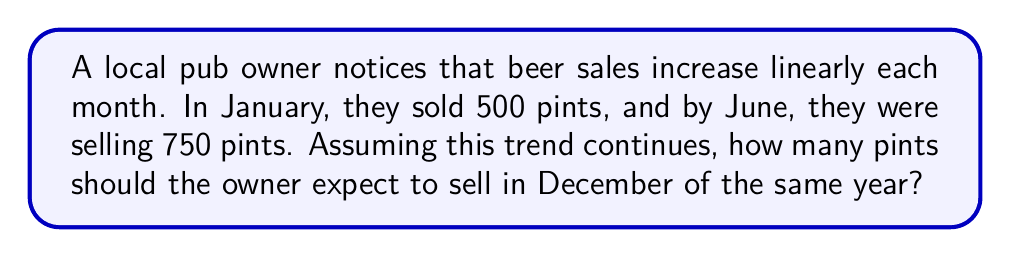Show me your answer to this math problem. Let's approach this step-by-step:

1) First, we need to find the rate of increase per month.
   We have 6 months (January to June) and an increase from 500 to 750 pints.

   Rate of increase = $\frac{750 - 500}{6-1} = \frac{250}{5} = 50$ pints per month

2) Now we can set up a linear equation:
   $y = mx + b$, where
   $y$ is the number of pints sold
   $m$ is the rate of increase (50)
   $x$ is the number of months since January
   $b$ is the initial value (500 in January)

   So our equation is: $y = 50x + 500$

3) December is the 12th month, so $x = 11$ (as January is month 0)

4) Let's plug this into our equation:
   $y = 50(11) + 500$
   $y = 550 + 500$
   $y = 1050$

Therefore, the owner should expect to sell 1050 pints in December.
Answer: 1050 pints 